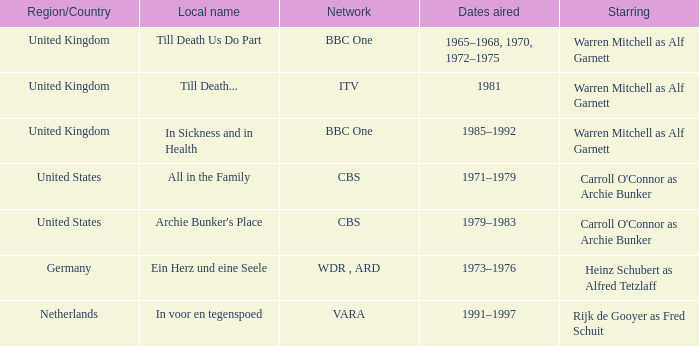What are the air dates for the episodes in the united states? 1971–1979, 1979–1983. 